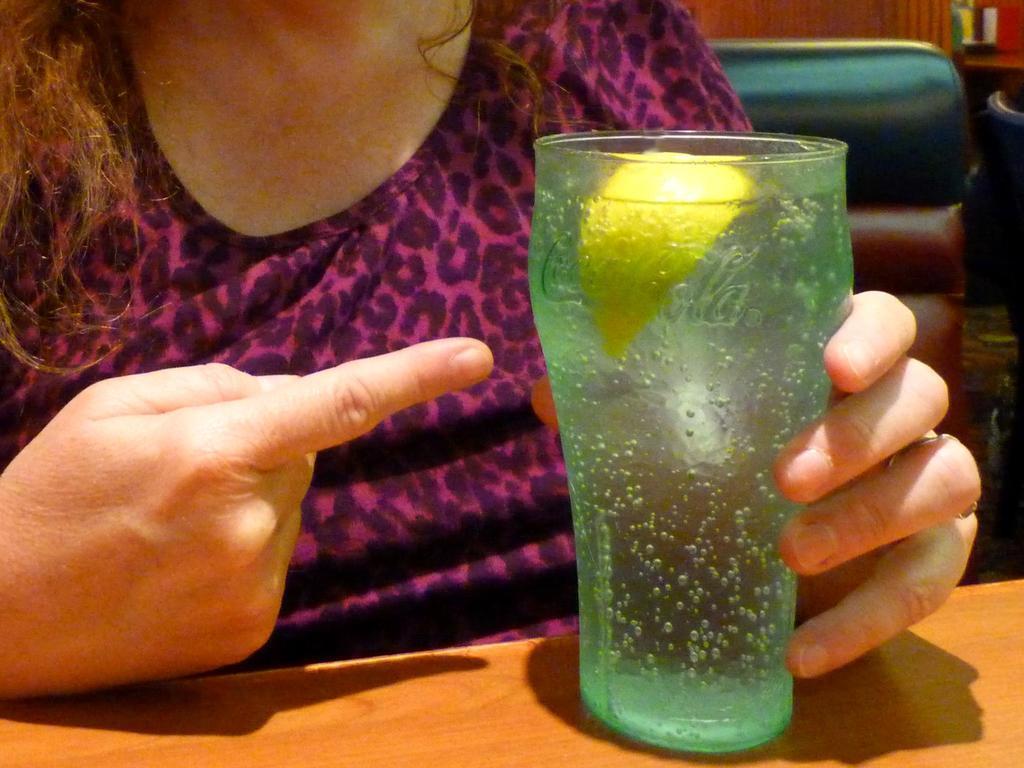In one or two sentences, can you explain what this image depicts? In the background we can see objects. In this picture we can see the partial part of a person holding a glass. We can see lime slice and liquid in a glass. At the bottom portion of the picture we can see wooden surface. 